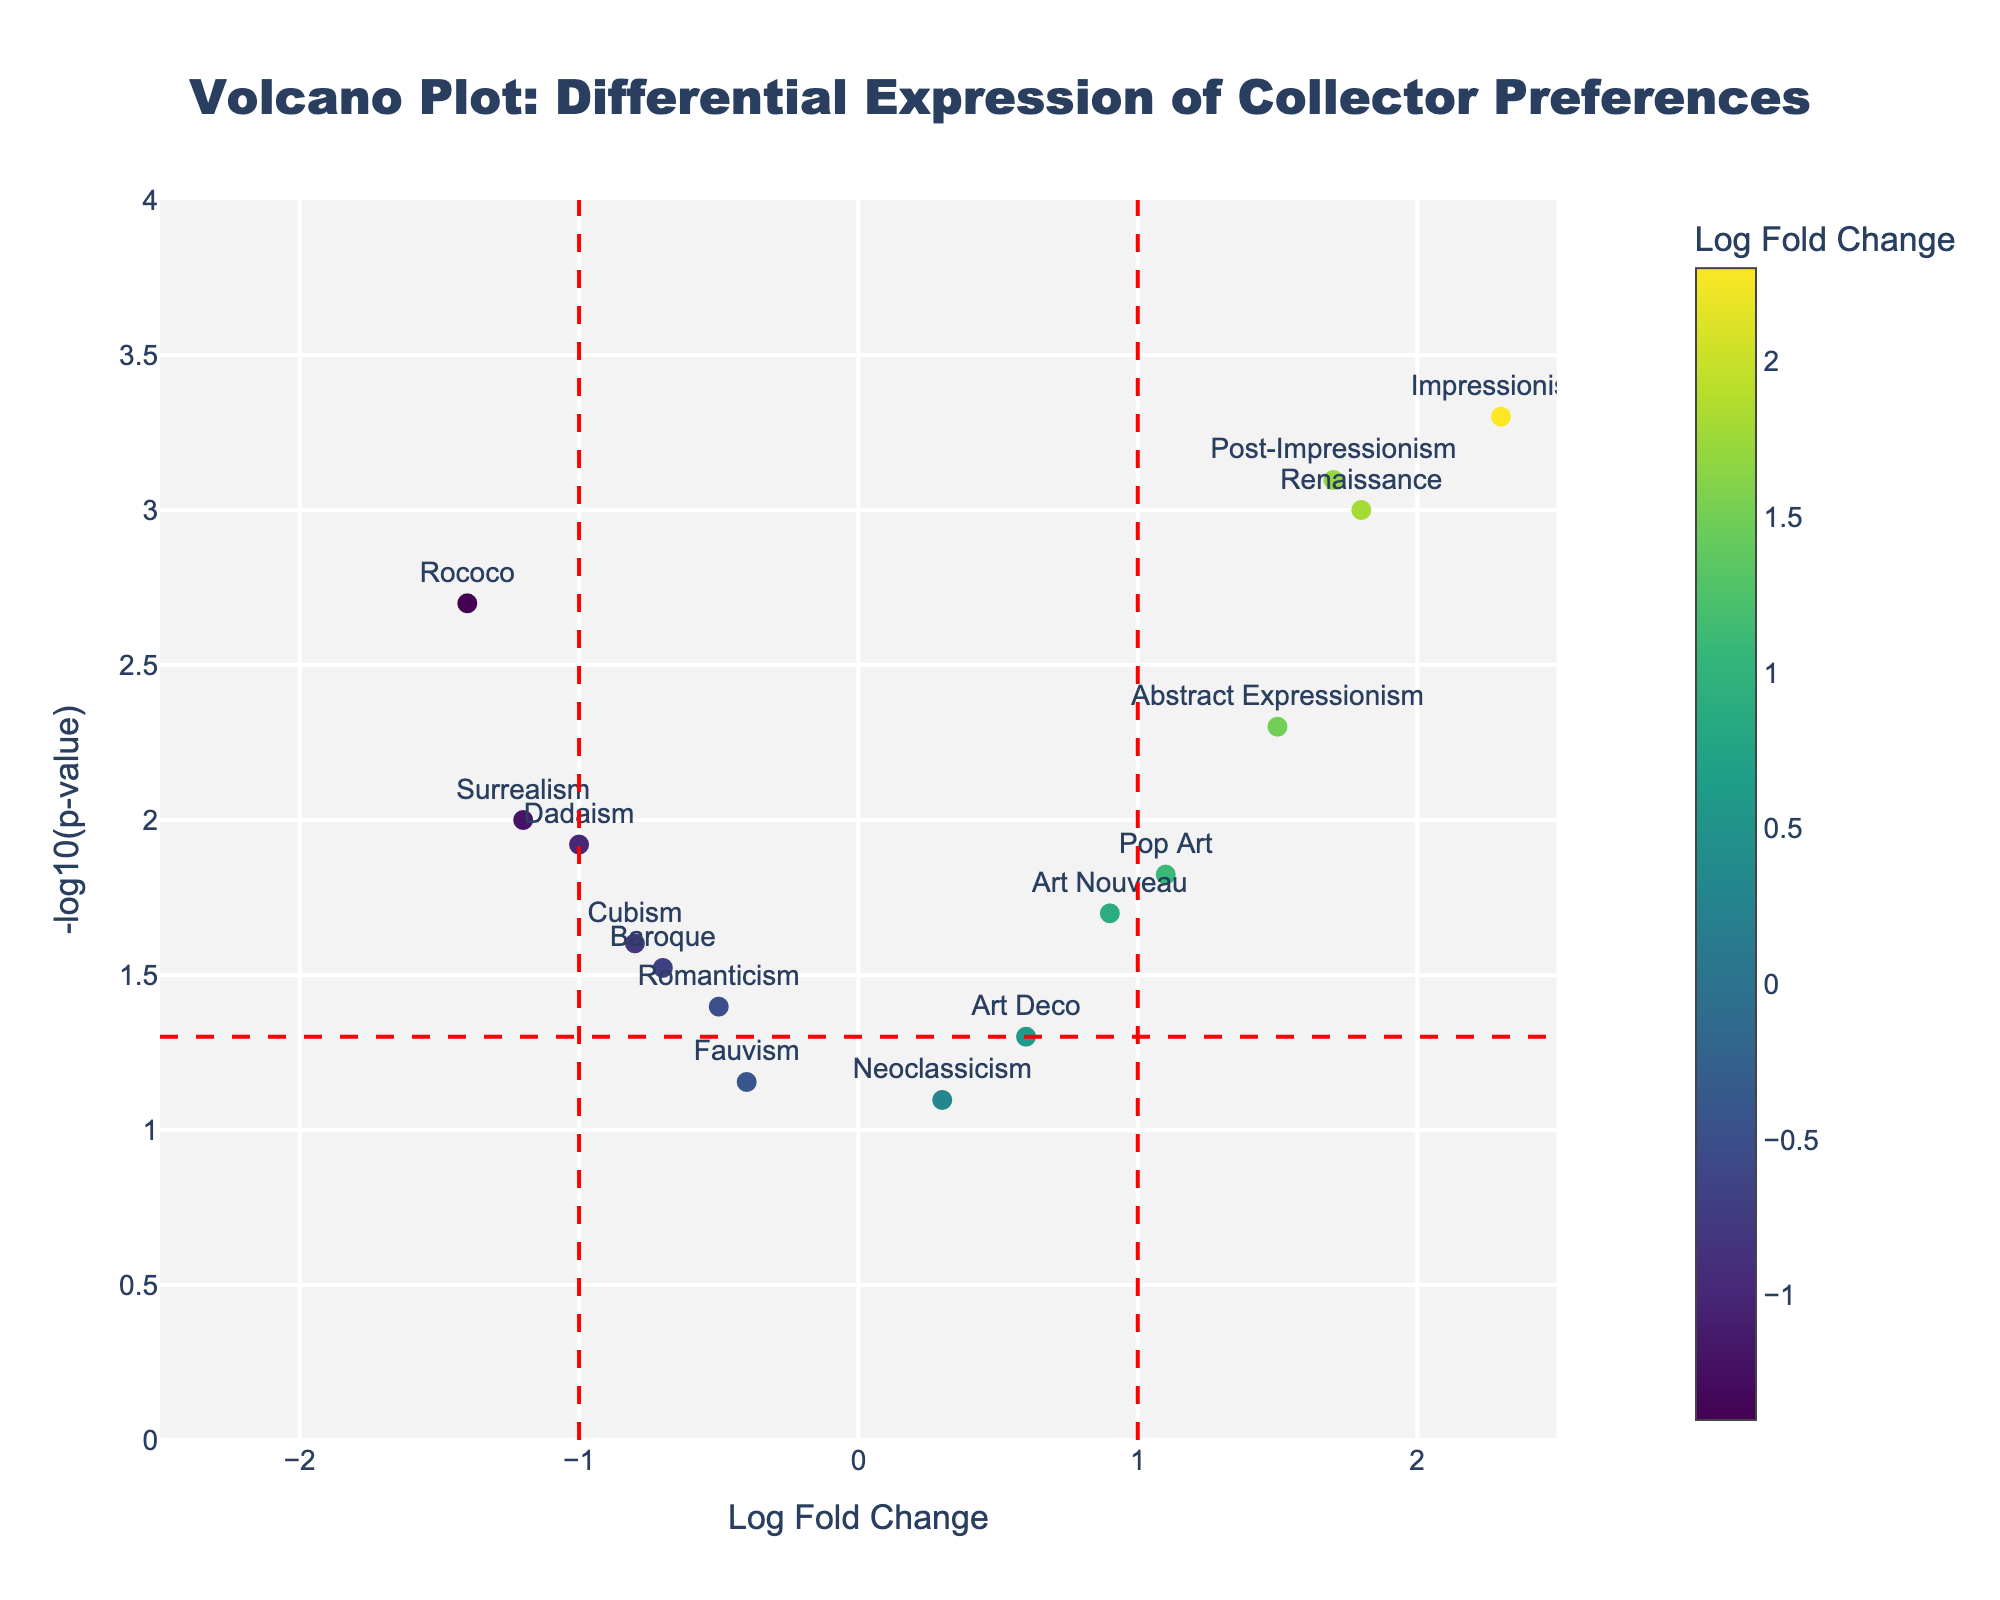Which art period shows the highest Log Fold Change? By looking at the x-axis (Log Fold Change), we identify the point that is furthest to the right. The art period associated with this point shows the highest Log Fold Change.
Answer: Impressionism How many art periods have a p-value less than 0.05? The horizontal red dashed line in the figure indicates the p-value threshold of 0.05. We count the markers that are above this line.
Answer: 10 Which art period has the lowest -log10(p-value)? By looking at the y-axis (-log10(p-value)), we find the point with the lowest y-coordinate value. The art period associated with this point has the lowest -log10(p-value).
Answer: Neoclassicism Which art period appears on the left side of the plot (negative Log Fold Change) and has a p-value lower than 0.01? We focus on points with a negative Log Fold Change (left of the vertical dashed lines) and above the horizontal red dashed line (-log10(p-value) > 2). The art period with these conditions is identified.
Answer: Surrealism Which art periods have both Log Fold Change greater than 1 and p-value less than 0.01? Identify markers to the right of the vertical dashed line at 1 (Log Fold Change > 1) and above the horizontal red dashed line (-log10(p-value) > 2).
Answer: Renaissance, Impressionism, Abstract Expressionism, Post-Impressionism What is the Log Fold Change and p-value of Dadaism? Locate the marker labeled "Dadaism" on the plot and read off its Log Fold Change (x-axis) and -log10(p-value) (y-axis). The p-value can be deduced from the -log10(p-value).
Answer: -1.0, 0.012 How many art periods have a Log Fold Change between -1 and 1? Count the markers that are between the two vertical red dashed lines at -1 and 1 on the x-axis.
Answer: 5 Which art period shows the most significant negative preference (lowest Log Fold Change)? Identify the point furthest to the left on the x-axis and check the label to find the art period.
Answer: Rococo Which art periods have a -log10(p-value) higher than 3? Identify markers above the level of 3 on the y-axis (-log10(p-value)).
Answer: Impressionism, Post-Impressionism What is the relationship between the Log Fold Change and p-value for Romanticism? Locate Romanticism on the plot and observe its position relative to the axes and reference lines. Determine Log Fold Change and p-value based on its position.
Answer: -0.5, 0.04 